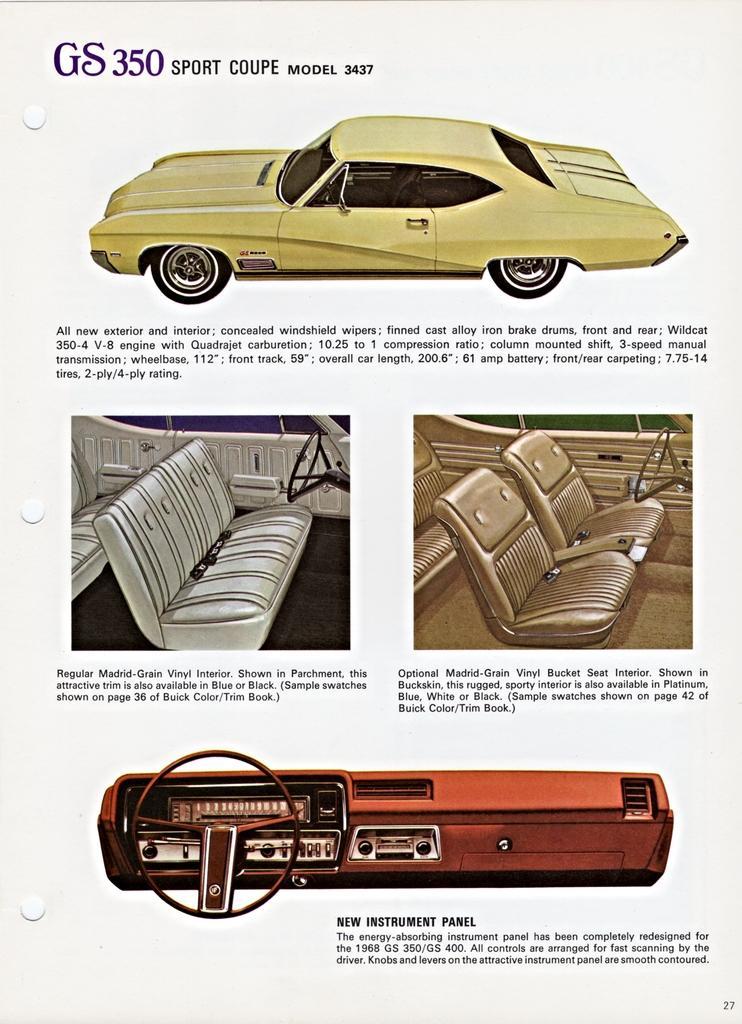Please provide a concise description of this image. In this image there is a poster, on that poster there are car pictures and some text. 